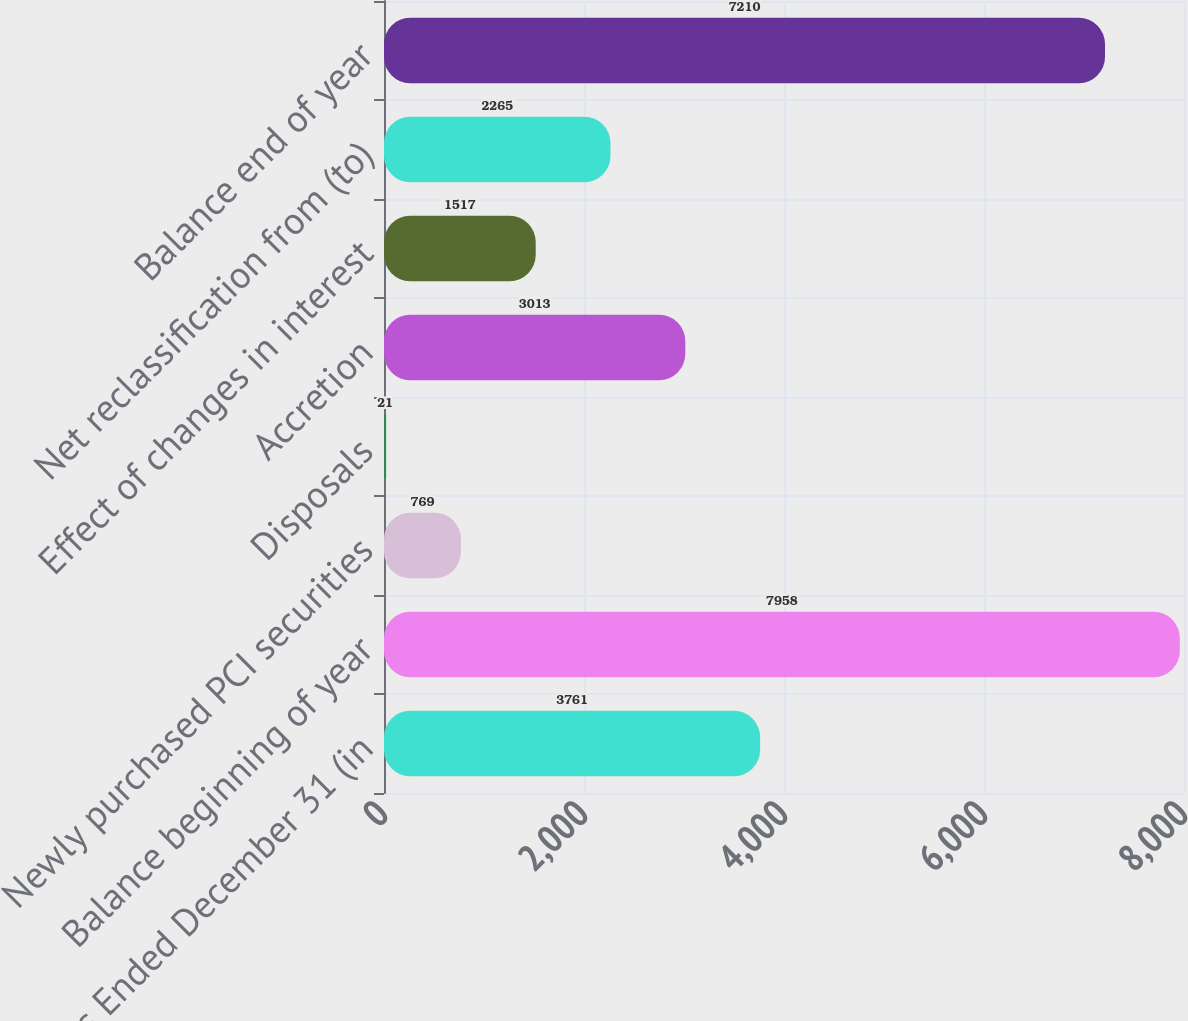Convert chart to OTSL. <chart><loc_0><loc_0><loc_500><loc_500><bar_chart><fcel>Years Ended December 31 (in<fcel>Balance beginning of year<fcel>Newly purchased PCI securities<fcel>Disposals<fcel>Accretion<fcel>Effect of changes in interest<fcel>Net reclassification from (to)<fcel>Balance end of year<nl><fcel>3761<fcel>7958<fcel>769<fcel>21<fcel>3013<fcel>1517<fcel>2265<fcel>7210<nl></chart> 